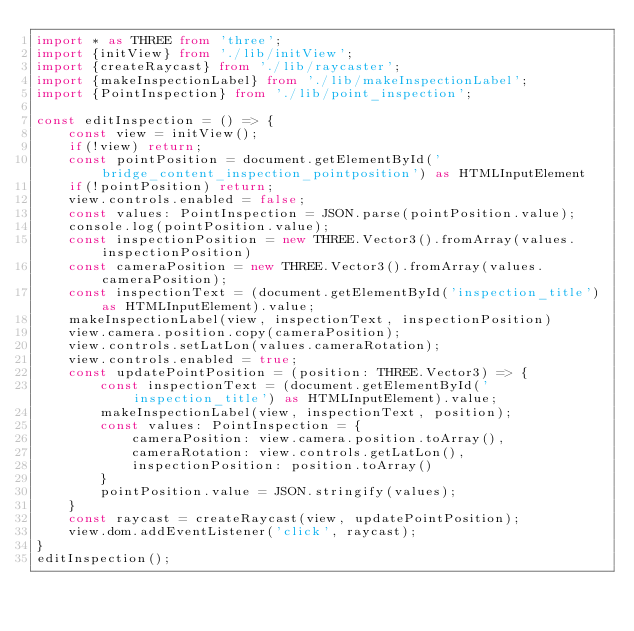Convert code to text. <code><loc_0><loc_0><loc_500><loc_500><_TypeScript_>import * as THREE from 'three';
import {initView} from './lib/initView';
import {createRaycast} from './lib/raycaster';
import {makeInspectionLabel} from './lib/makeInspectionLabel';
import {PointInspection} from './lib/point_inspection';

const editInspection = () => {
    const view = initView();
    if(!view) return;
    const pointPosition = document.getElementById('bridge_content_inspection_pointposition') as HTMLInputElement
    if(!pointPosition) return;
    view.controls.enabled = false;
    const values: PointInspection = JSON.parse(pointPosition.value);
    console.log(pointPosition.value);
    const inspectionPosition = new THREE.Vector3().fromArray(values.inspectionPosition)
    const cameraPosition = new THREE.Vector3().fromArray(values.cameraPosition);
    const inspectionText = (document.getElementById('inspection_title') as HTMLInputElement).value;
    makeInspectionLabel(view, inspectionText, inspectionPosition)
    view.camera.position.copy(cameraPosition);
    view.controls.setLatLon(values.cameraRotation);
    view.controls.enabled = true;
    const updatePointPosition = (position: THREE.Vector3) => {
        const inspectionText = (document.getElementById('inspection_title') as HTMLInputElement).value;
        makeInspectionLabel(view, inspectionText, position);
        const values: PointInspection = {
            cameraPosition: view.camera.position.toArray(),
            cameraRotation: view.controls.getLatLon(),
            inspectionPosition: position.toArray()
        }
        pointPosition.value = JSON.stringify(values);
    }
    const raycast = createRaycast(view, updatePointPosition);
    view.dom.addEventListener('click', raycast);
}
editInspection();
</code> 